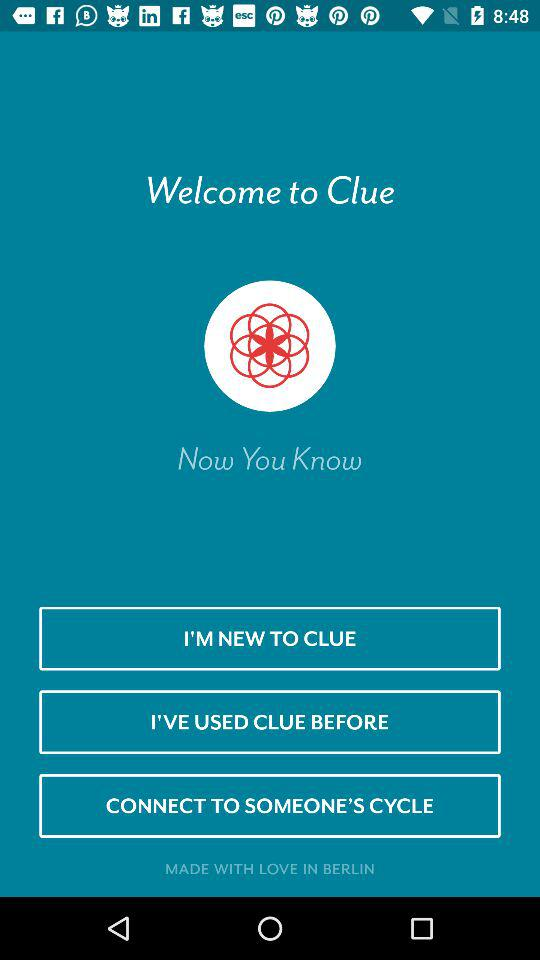What is the name of the application? The name of the application is "Clue". 